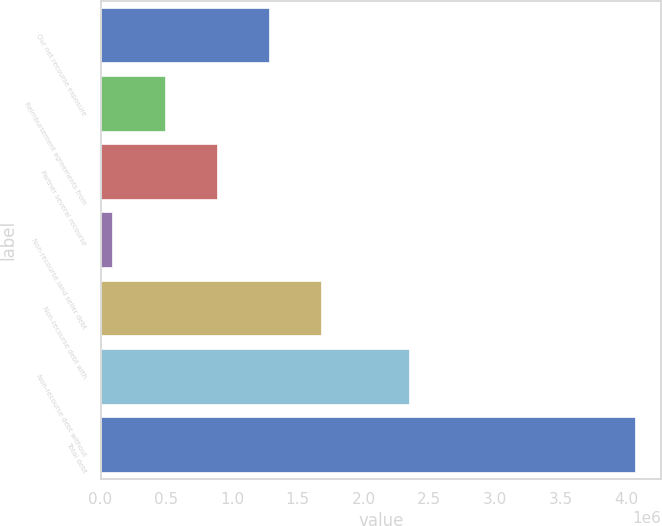<chart> <loc_0><loc_0><loc_500><loc_500><bar_chart><fcel>Our net recourse exposure<fcel>Reimbursement agreements from<fcel>Partner several recourse<fcel>Non-recourse land seller debt<fcel>Non-recourse debt with<fcel>Non-recourse debt without<fcel>Total debt<nl><fcel>1.28198e+06<fcel>487673<fcel>884827<fcel>90519<fcel>1.67913e+06<fcel>2.34571e+06<fcel>4.06206e+06<nl></chart> 